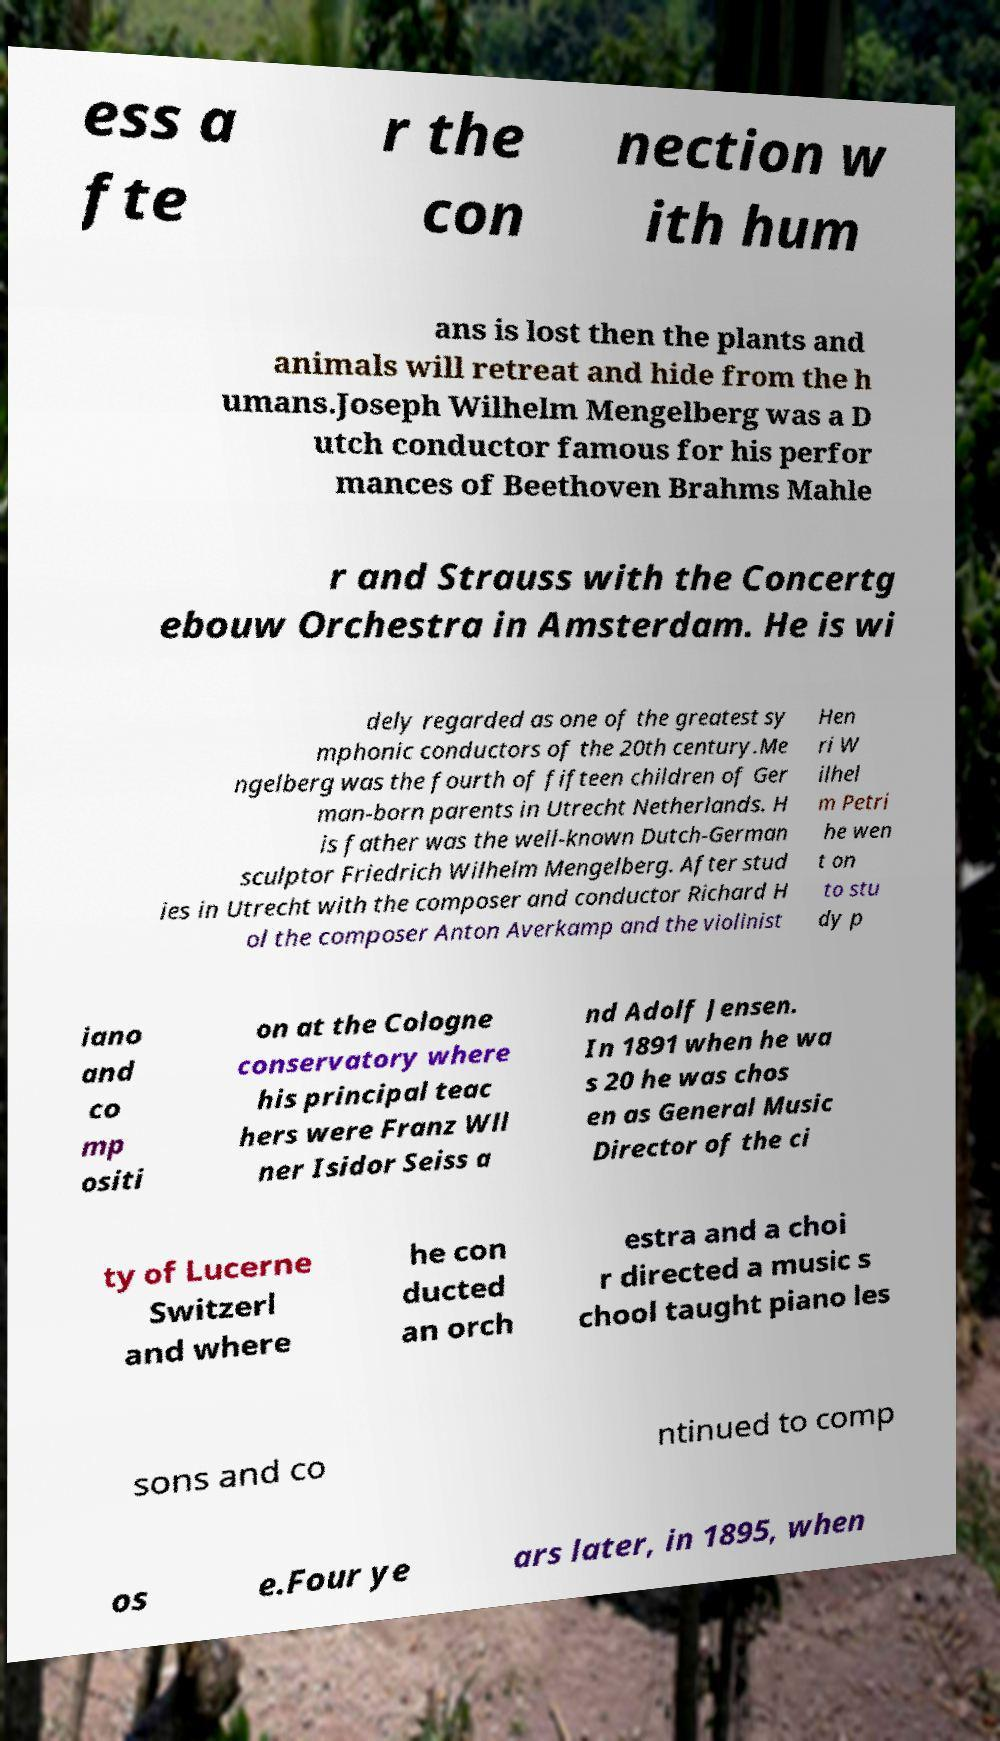Could you assist in decoding the text presented in this image and type it out clearly? ess a fte r the con nection w ith hum ans is lost then the plants and animals will retreat and hide from the h umans.Joseph Wilhelm Mengelberg was a D utch conductor famous for his perfor mances of Beethoven Brahms Mahle r and Strauss with the Concertg ebouw Orchestra in Amsterdam. He is wi dely regarded as one of the greatest sy mphonic conductors of the 20th century.Me ngelberg was the fourth of fifteen children of Ger man-born parents in Utrecht Netherlands. H is father was the well-known Dutch-German sculptor Friedrich Wilhelm Mengelberg. After stud ies in Utrecht with the composer and conductor Richard H ol the composer Anton Averkamp and the violinist Hen ri W ilhel m Petri he wen t on to stu dy p iano and co mp ositi on at the Cologne conservatory where his principal teac hers were Franz Wll ner Isidor Seiss a nd Adolf Jensen. In 1891 when he wa s 20 he was chos en as General Music Director of the ci ty of Lucerne Switzerl and where he con ducted an orch estra and a choi r directed a music s chool taught piano les sons and co ntinued to comp os e.Four ye ars later, in 1895, when 